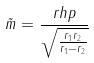<formula> <loc_0><loc_0><loc_500><loc_500>\tilde { m } = \frac { r h p } { \sqrt { \frac { r _ { 1 } r _ { 2 } } { r _ { 1 } - r _ { 2 } } } }</formula> 